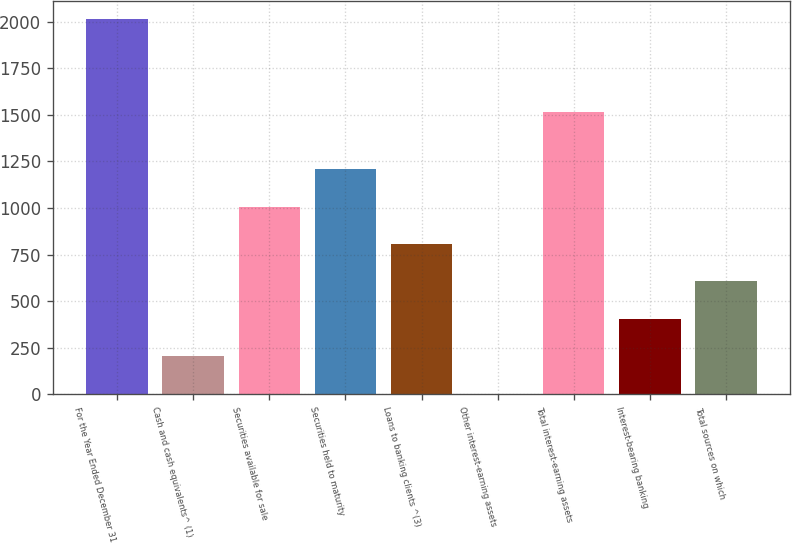Convert chart to OTSL. <chart><loc_0><loc_0><loc_500><loc_500><bar_chart><fcel>For the Year Ended December 31<fcel>Cash and cash equivalents^ (1)<fcel>Securities available for sale<fcel>Securities held to maturity<fcel>Loans to banking clients ^(3)<fcel>Other interest-earning assets<fcel>Total interest-earning assets<fcel>Interest-bearing banking<fcel>Total sources on which<nl><fcel>2013<fcel>203.1<fcel>1007.5<fcel>1208.6<fcel>806.4<fcel>2<fcel>1513<fcel>404.2<fcel>605.3<nl></chart> 